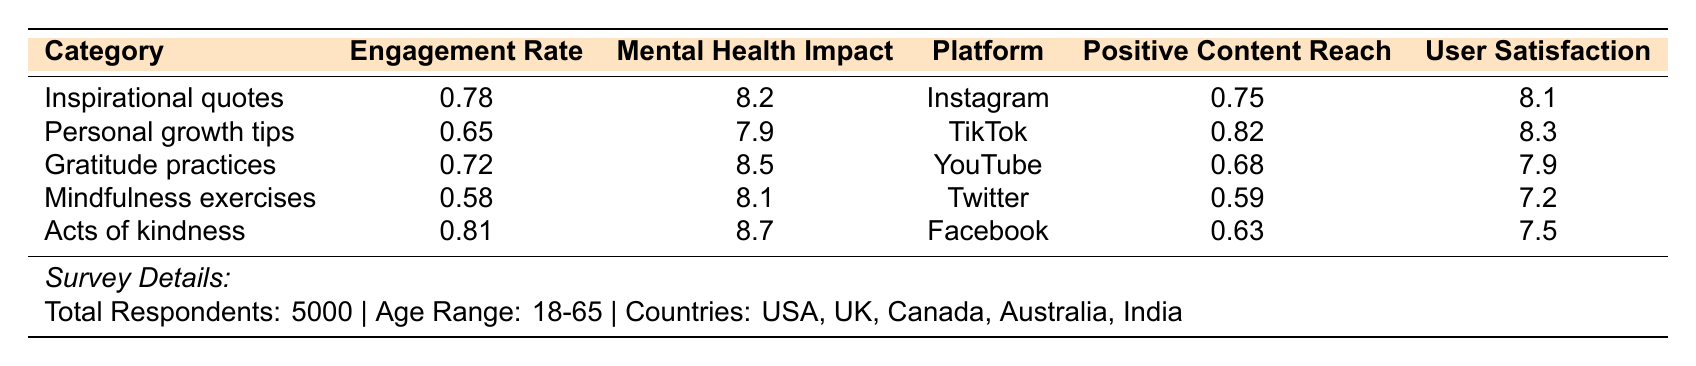What is the engagement rate for "Acts of kindness"? Referring to the table, the engagement rate for "Acts of kindness" is listed as 0.81.
Answer: 0.81 Which category has the highest mental health impact score? The table shows that the category "Acts of kindness" has the highest mental health impact score at 8.7.
Answer: Acts of kindness What is the average user satisfaction for all platforms? To find the average user satisfaction, sum the satisfaction scores: (8.1 + 8.3 + 7.9 + 7.2 + 7.5) = 38. To get the average, divide by the number of platforms: 38/5 = 7.6.
Answer: 7.6 Is the positive content reach higher on TikTok or Instagram? The table presents TikTok's positive content reach as 0.82 and Instagram's as 0.75. Since 0.82 is greater than 0.75, TikTok has a higher reach.
Answer: Yes, it's higher on TikTok Which platform has the lowest user satisfaction score? Looking at the table, Twitter has the lowest user satisfaction score of 7.2 compared to the other platforms.
Answer: Twitter What is the difference in mental health impact score between "Inspirational quotes" and "Personal growth tips"? The mental health impact score for "Inspirational quotes" is 8.2 and for "Personal growth tips" is 7.9. The difference is 8.2 - 7.9 = 0.3.
Answer: 0.3 How many categories have a mental health impact score higher than 8.0? By examining the scores, "Acts of kindness" (8.7), "Gratitude practices" (8.5), and "Inspirational quotes" (8.2) all have scores above 8.0. That makes a total of 3 categories.
Answer: 3 What is the user satisfaction score for Facebook compared to the average user satisfaction? The user satisfaction score for Facebook is 7.5. The average satisfaction is 7.6 (calculated previously). Facebook's score is slightly lower than the average.
Answer: Lower than average Which category has the lowest engagement rate? The table indicates that "Mindfulness exercises" has the lowest engagement rate at 0.58.
Answer: Mindfulness exercises What percentage of respondents follows positive content creators? From the data given, 4 out of 5 respondents follow positive content creators. Thus, the percentage is (4/5) * 100 = 80%.
Answer: 80% 